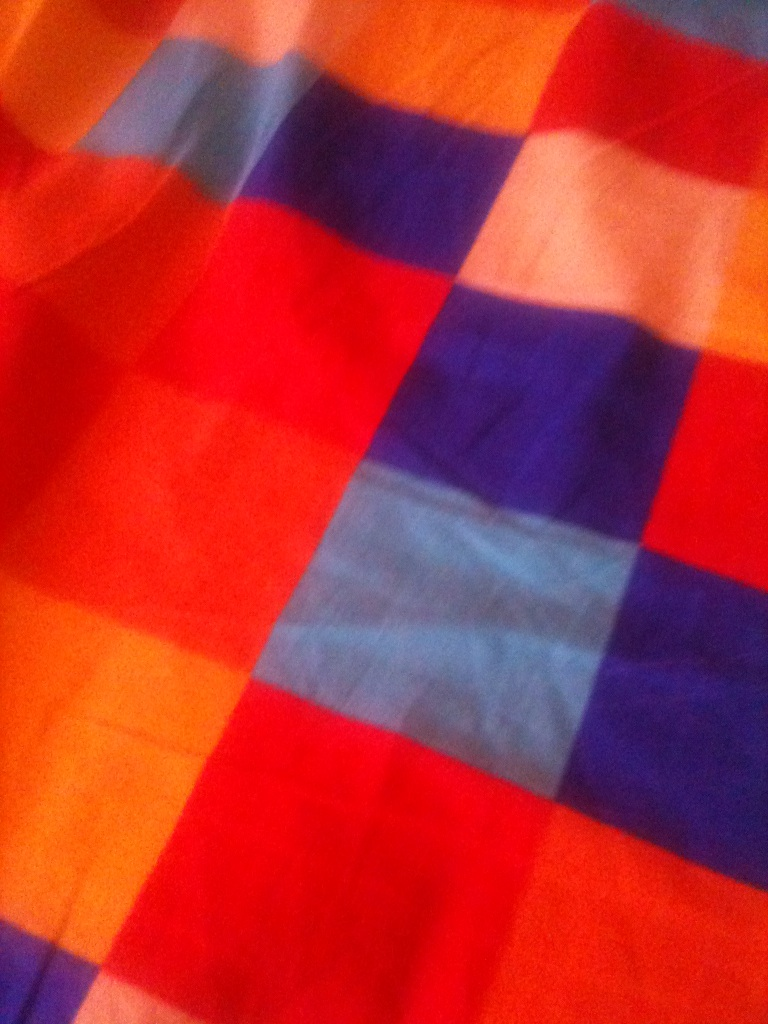What kind of pattern do you see in this image? The image displays a checkered pattern, made up of squares in various colors such as red, blue, orange, and hints of pink or purple. This type of pattern is often used in fabric and textiles, giving a playful and vibrant look. How would you describe the texture of the fabric? The fabric appears to be lightweight and might be made of a soft material, like cotton or a cotton blend. The way the colors blend together suggests that it has a smooth surface, which would feel comfortable against the skin. If you were to design an outfit using this fabric, what would you create? I would use this colorful, checkered fabric to design a vibrant summer dress. The dress would be a midi-length with a flared skirt, fitted bodice, and thin shoulder straps. This playful pattern would also be perfect for a casual shirt or a light scarf, adding a pop of color to any outfit. Imagine this fabric were part of a magical tapestry. What might the tapestry depict, and how would it interact with its surroundings? In a fantastical realm, this fabric could be part of a magical tapestry that depicts a lively forest filled with mythical creatures, each square representing a different scene—an elf gathering herbs, a dragon flying over a waterfall, and a unicorn resting under a rainbow. This enchanted tapestry might shimmer and change its pattern, reflecting the emotions and thoughts of those near it, creating a dynamic storytelling canvas that interacts with its viewers in a truly magical manner. 